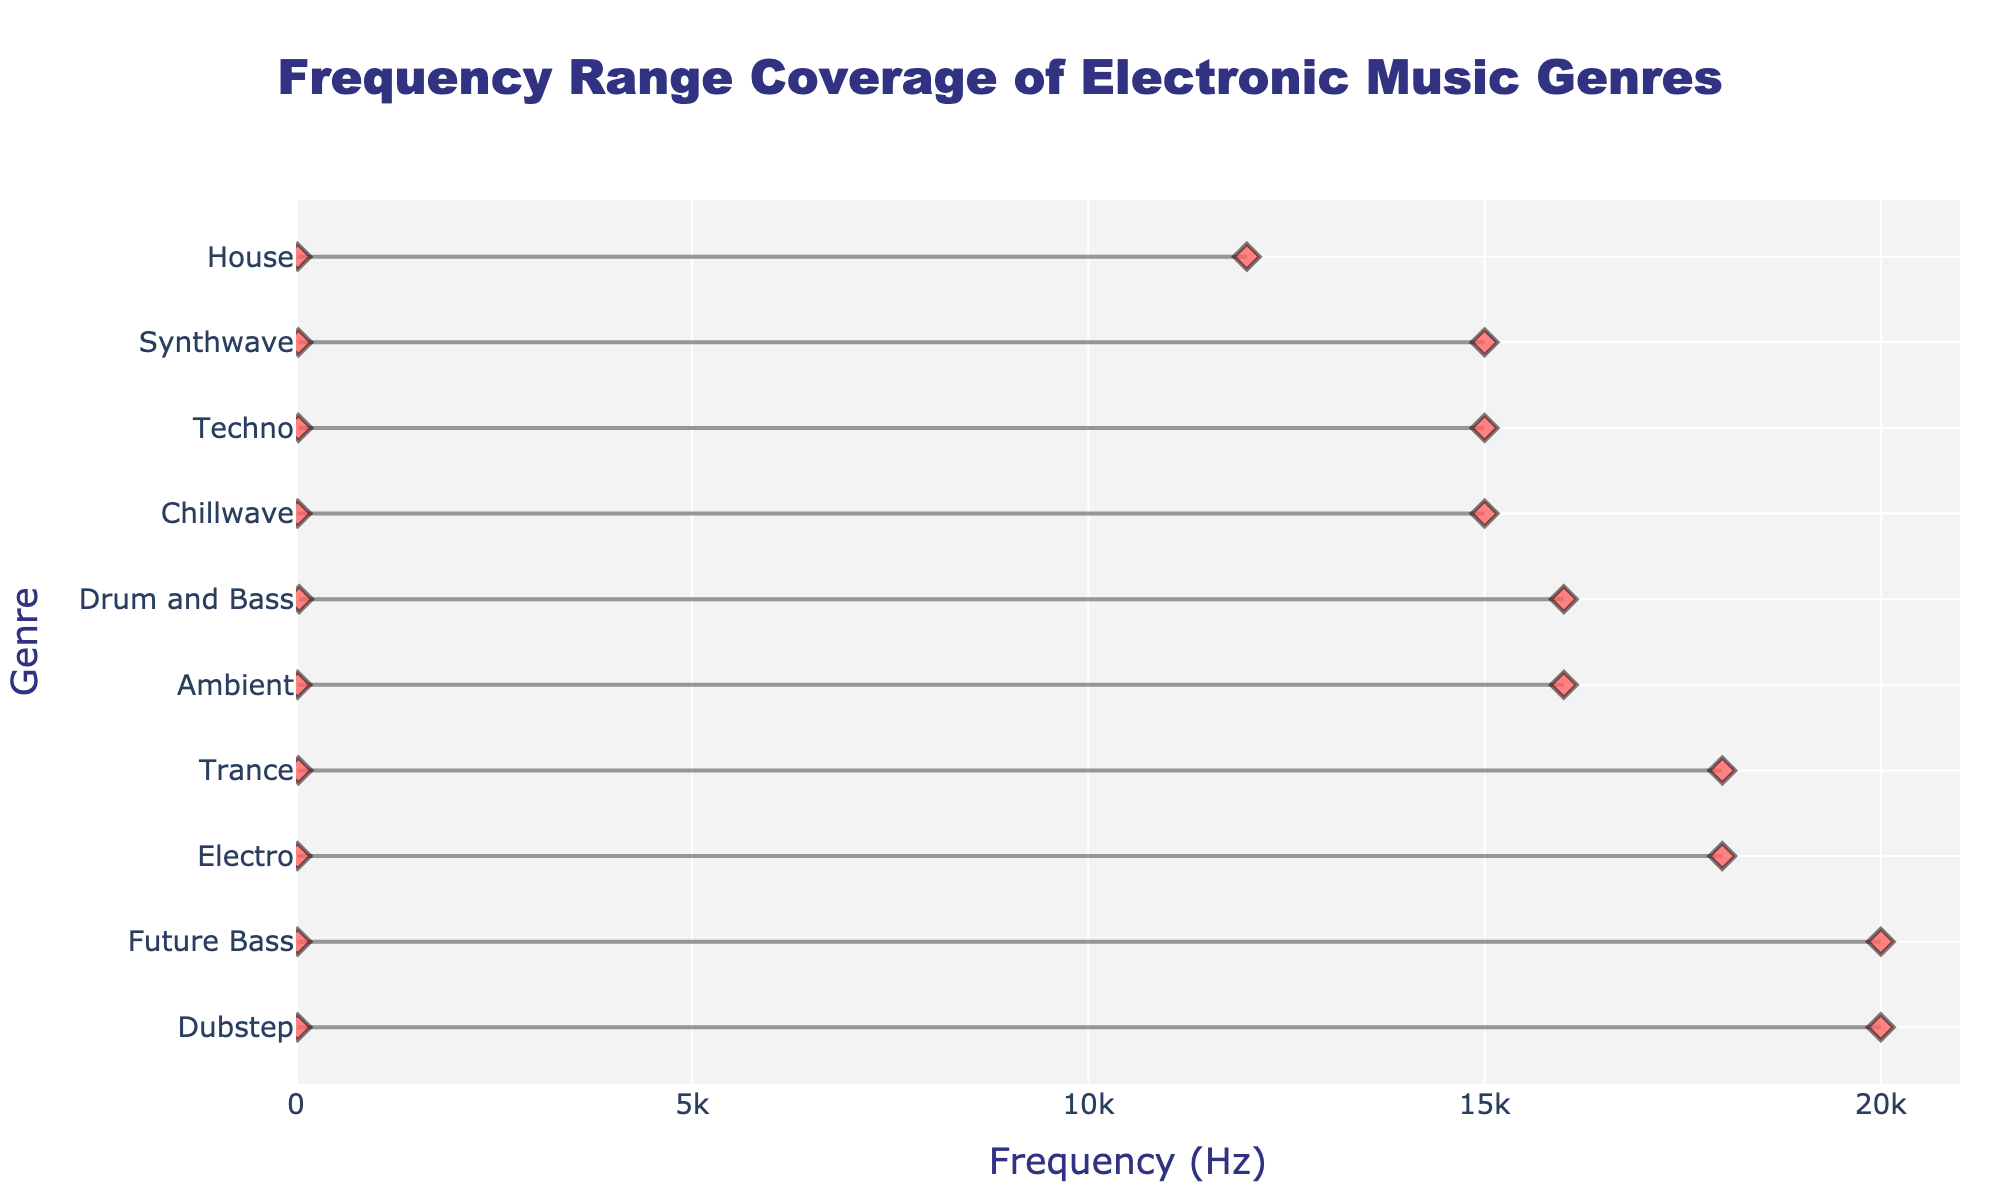What's the title of the plot? The title is displayed prominently at the top of the figure.
Answer: Frequency Range Coverage of Electronic Music Genres What is the frequency range for Drum and Bass? The frequency range for Drum and Bass is depicted by the line span between the markers labeled as 'Drum and Bass'.
Answer: 40 Hz to 16000 Hz Which genre has the widest frequency range? By examining the span of each genre, Dubstep and Future Bass have the widest frequency range, from 20 Hz to 20000 Hz.
Answer: Dubstep and Future Bass Which genre has the narrowest frequency range? The genre with the shortest span between the markers indicates the narrowest frequency range, which is House.
Answer: House How does the frequency range of Chillwave compare to that of Techno? Comparing the spans, Chillwave ranges from 20 Hz to 15000 Hz, while Techno ranges from 30 Hz to 15000 Hz. Chillwave covers a slightly lower minimum frequency.
Answer: Chillwave has a lower minimum frequency What is the average maximum frequency covered by all genres? Sum all maximum frequencies (16000 + 15000 + 12000 + 20000 + 16000 + 18000 + 18000 + 15000 + 15000 + 20000) which equals 165000 Hz, then divide by 10.
Answer: 16500 Hz Which genres cover frequencies starting from 20 Hz? Identify the genres with minimum frequency at 20 Hz: Ambient, House, Dubstep, Electro, Chillwave, and Future Bass.
Answer: Ambient, House, Dubstep, Electro, Chillwave, and Future Bass Between Drum and Bass and Synthwave, which one covers a higher maximum frequency? Drum and Bass covers up to 16000 Hz while Synthwave covers up to 15000 Hz.
Answer: Drum and Bass What is the difference in the maximum frequency coverage between Ambient and House? Ambient's maximum frequency is 16000 Hz, and House's maximum frequency is 12000 Hz. The difference is 16000 - 12000.
Answer: 4000 Hz Which genre has a minimum frequency of 30 Hz and what is its maximum frequency? Identify the genre with a minimum frequency of 30 Hz, which includes Techno, Trance, and Synthwave. Then check their maximum frequencies.
Answer: Techno: 15000 Hz, Trance: 18000 Hz, Synthwave: 15000 Hz 